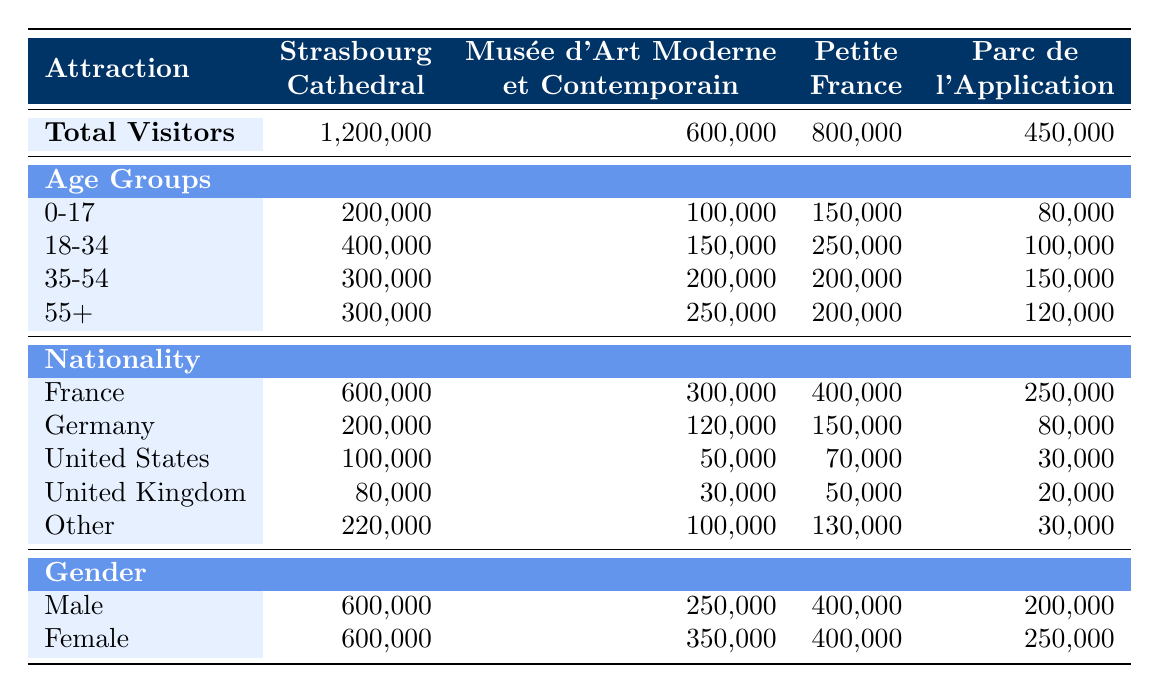What is the total number of visitors to the Strasbourg Cathedral? The total number of visitors for each attraction is listed in the first row of the table. For the Strasbourg Cathedral, the value is clearly stated as 1,200,000.
Answer: 1,200,000 How many visitors aged 18-34 visited the Musée d'Art Moderne et Contemporain? The age group 18-34 for the Musée d'Art Moderne et Contemporain is found in the age groups section of the table. The number of visitors in this category is 150,000.
Answer: 150,000 Is the number of visitors from Germany to Petite France greater than those from the United Kingdom? The number of visitors from Germany to Petite France is 150,000, while the number from the United Kingdom is 50,000. Since 150,000 is greater than 50,000, the statement is true.
Answer: Yes What is the total number of visitors older than 55 years for all attractions combined? To find this, we add the number of visitors aged 55+ from each attraction: 300,000 (Strasbourg Cathedral) + 250,000 (Musée d'Art Moderne et Contemporain) + 200,000 (Petite France) + 120,000 (Parc de l'Application) = 870,000.
Answer: 870,000 What percentage of the total visitors to Parc de l'Application are male? The total number of visitors to Parc de l'Application is 450,000, and the number of male visitors is 200,000. The percentage is calculated by (200,000 / 450,000) * 100, which equals approximately 44.44%.
Answer: 44.44% Which attraction has the highest number of visitors from the United States? The United States visitor numbers for each attraction are as follows: Strasbourg Cathedral has 100,000, Musée d'Art Moderne et Contemporain has 50,000, Petite France has 70,000, and Parc de l'Application has 30,000. The highest number is from Strasbourg Cathedral at 100,000.
Answer: Strasbourg Cathedral How many more female visitors were there than male visitors at the Musée d'Art Moderne et Contemporain? For the Musée d'Art Moderne et Contemporain, there are 350,000 female visitors and 250,000 male visitors. The difference is 350,000 - 250,000 = 100,000 more female visitors.
Answer: 100,000 Are there an equal number of male and female visitors to Petite France? The number of male visitors to Petite France is 400,000, and the number of female visitors is also 400,000. Since both numbers are equal, the answer is yes.
Answer: Yes 